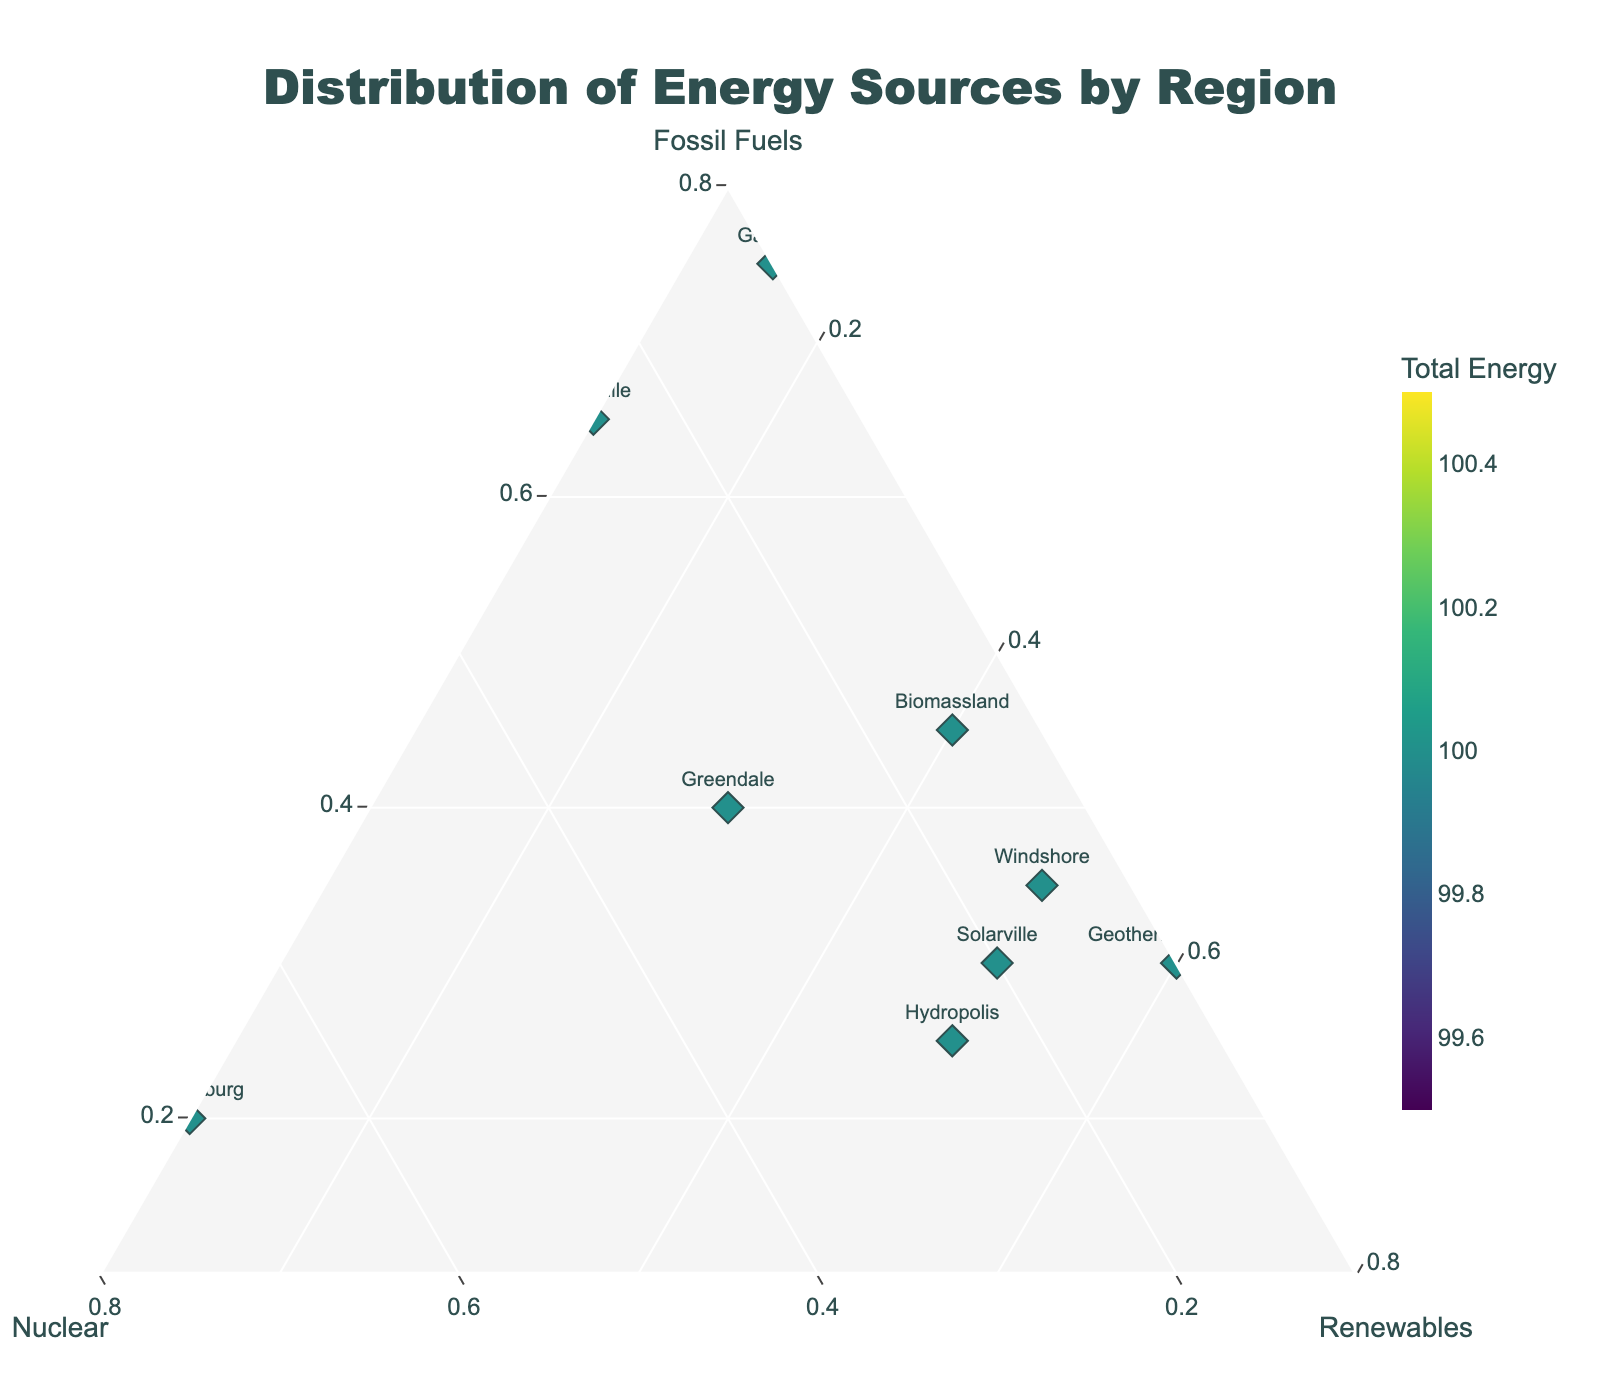What's the title of the plot? The title of the plot is displayed at the top center of the figure.
Answer: Distribution of Energy Sources by Region How many regions are represented in the plot? Count the number of unique labels (regions) in the plot.
Answer: 10 Which region has the highest nuclear energy proportion? Identify the point closest to the Nuclear axis. The closest point on the Nuclear axis represents the region with the highest nuclear energy proportion.
Answer: Nuclearburg Which regions have the highest combined proportion of renewables and nuclear energy? Look for regions with data points located towards the Nuclear and Renewables axes (away from the Fossil Fuels axis).
Answer: Solarville, Windshore, Hydropolis, Nuclearburg Which region has the smallest total energy proportion? The size of the markers indicates the total energy proportion. Identify the smallest marker.
Answer: Windshore What is the relation between Nuclearburg and Coaltown in terms of fossil fuel usage? Compare the position of Nuclearburg and Coaltown along the Fossil Fuels axis. Nuclearburg is further away from the Fossil Fuels axis compared to Coaltown.
Answer: Coaltown has a higher fossil fuel usage than Nuclearburg Which region has the highest proportion of renewable energy? Identify the marker closest to the Renewables axis.
Answer: Geothermal Springs What is the color of the marker representing Solarville, and what does it indicate? Identify the color of the marker for Solarville. The color indicates the total energy proportion, where darker colors represent higher total energy.
Answer: Dark green, indicating a high total energy proportion Across all regions, which type of energy source varies the most in proportion? Compare the spread of points along each axis. The axis with the widest spread (variation) indicates the energy source with the most varied proportion.
Answer: Fossil Fuels 